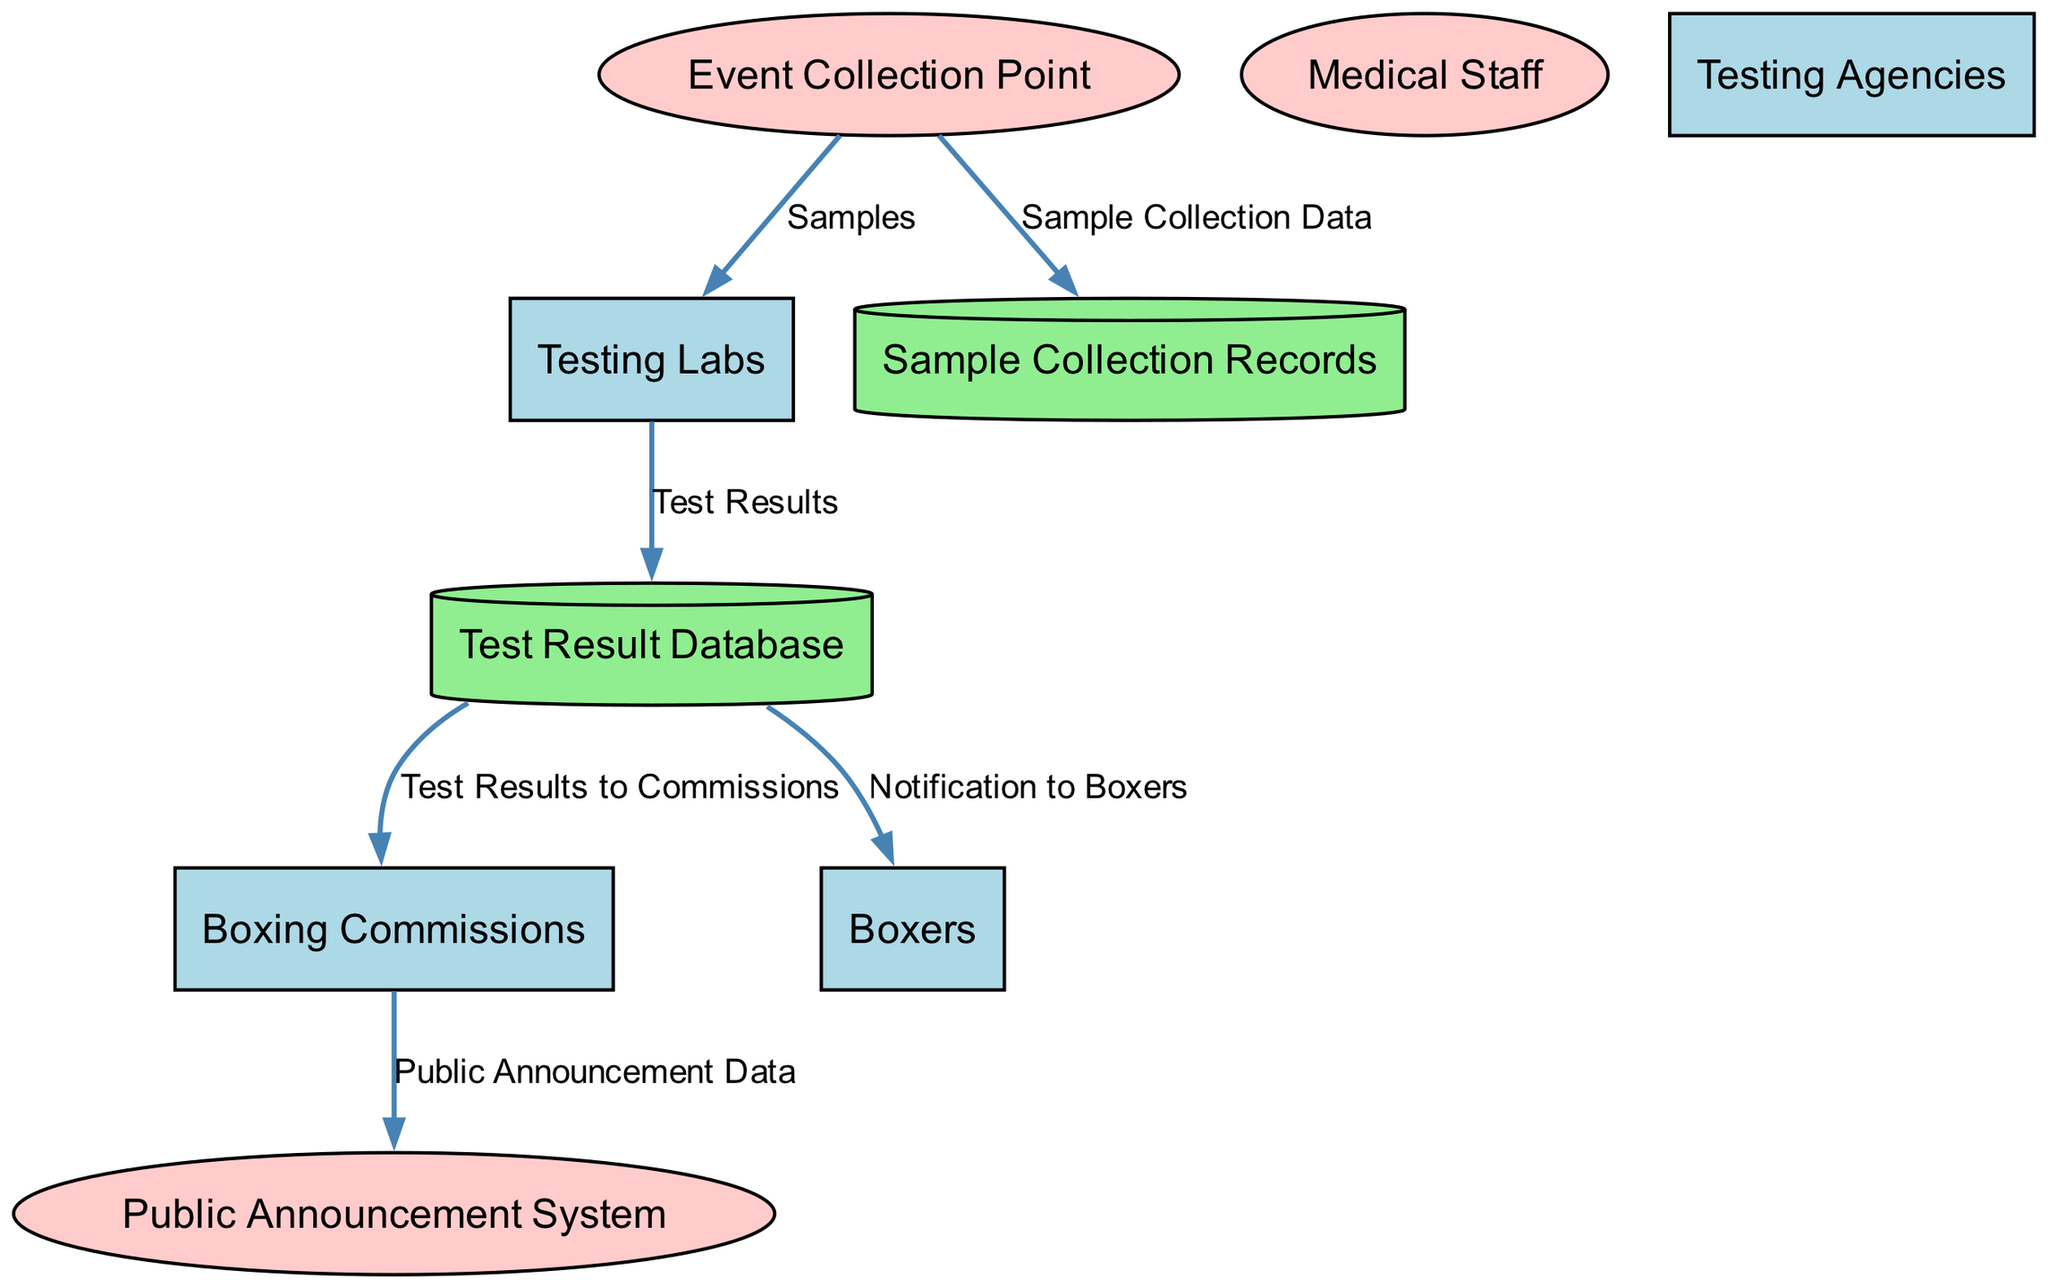What is the first entity in the data flow? The data flow starts at the "Event Collection Point," which is where the initial samples are collected from boxers during events.
Answer: Event Collection Point How many external entities are present in the diagram? There are four external entities shown in the diagram: Testing Labs, Boxing Commissions, Testing Agencies, and Boxers. Counting them gives a total of four external entities.
Answer: Four What type of data does the "Sample Collection Data" represent? The "Sample Collection Data" represents the details of collected samples, which include specifics such as time, date, and boxer information.
Answer: Details of collected samples Which process communicates test results to boxers? The "Notification to Boxers" process serves the function of communicating individual results derived from the test results database to the concerned boxers.
Answer: Notification to Boxers What flows from the Testing Labs to the Test Result Database? The flow titled "Test Results" represents the doping test results that are sent from the Testing Labs to the Test Result Database following the analysis process.
Answer: Test Results What is the purpose of the Public Announcement System in the diagram? The Public Announcement System is used for disclosing test results publicly, as indicated by the flow "Public Announcement Data" that originates from the Boxing Commissions.
Answer: Disclosing test results What connects the Test Result Database to the Boxing Commissions? The "Test Results to Commissions" flow connects the Test Result Database to the Boxing Commissions, providing detailed test results for regulatory review.
Answer: Test Results to Commissions Which process is responsible for ensuring the integrity of samples? The "Medical Staff" is tasked with ensuring the integrity of samples collected from boxers during events, as depicted in the data flow diagram.
Answer: Medical Staff 